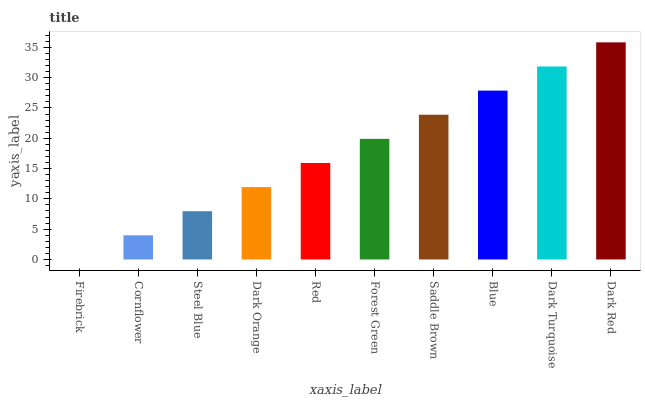Is Firebrick the minimum?
Answer yes or no. Yes. Is Dark Red the maximum?
Answer yes or no. Yes. Is Cornflower the minimum?
Answer yes or no. No. Is Cornflower the maximum?
Answer yes or no. No. Is Cornflower greater than Firebrick?
Answer yes or no. Yes. Is Firebrick less than Cornflower?
Answer yes or no. Yes. Is Firebrick greater than Cornflower?
Answer yes or no. No. Is Cornflower less than Firebrick?
Answer yes or no. No. Is Forest Green the high median?
Answer yes or no. Yes. Is Red the low median?
Answer yes or no. Yes. Is Saddle Brown the high median?
Answer yes or no. No. Is Forest Green the low median?
Answer yes or no. No. 